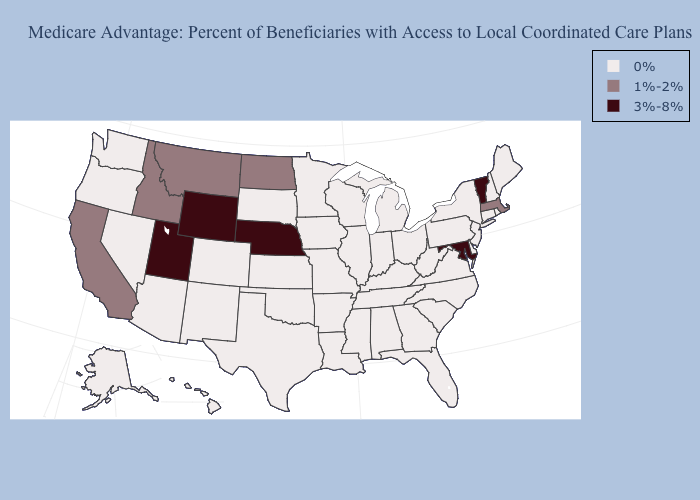Name the states that have a value in the range 3%-8%?
Be succinct. Maryland, Nebraska, Utah, Vermont, Wyoming. Name the states that have a value in the range 0%?
Be succinct. Colorado, Connecticut, Delaware, Florida, Georgia, Hawaii, Iowa, Illinois, Indiana, Kansas, Kentucky, Louisiana, Maine, Michigan, Minnesota, Missouri, Mississippi, North Carolina, New Hampshire, New Jersey, New Mexico, Nevada, New York, Ohio, Oklahoma, Oregon, Pennsylvania, Rhode Island, South Carolina, South Dakota, Alaska, Tennessee, Texas, Virginia, Washington, Wisconsin, West Virginia, Alabama, Arkansas, Arizona. Does the first symbol in the legend represent the smallest category?
Keep it brief. Yes. What is the lowest value in the USA?
Keep it brief. 0%. Name the states that have a value in the range 0%?
Concise answer only. Colorado, Connecticut, Delaware, Florida, Georgia, Hawaii, Iowa, Illinois, Indiana, Kansas, Kentucky, Louisiana, Maine, Michigan, Minnesota, Missouri, Mississippi, North Carolina, New Hampshire, New Jersey, New Mexico, Nevada, New York, Ohio, Oklahoma, Oregon, Pennsylvania, Rhode Island, South Carolina, South Dakota, Alaska, Tennessee, Texas, Virginia, Washington, Wisconsin, West Virginia, Alabama, Arkansas, Arizona. Does the first symbol in the legend represent the smallest category?
Concise answer only. Yes. Which states have the lowest value in the USA?
Keep it brief. Colorado, Connecticut, Delaware, Florida, Georgia, Hawaii, Iowa, Illinois, Indiana, Kansas, Kentucky, Louisiana, Maine, Michigan, Minnesota, Missouri, Mississippi, North Carolina, New Hampshire, New Jersey, New Mexico, Nevada, New York, Ohio, Oklahoma, Oregon, Pennsylvania, Rhode Island, South Carolina, South Dakota, Alaska, Tennessee, Texas, Virginia, Washington, Wisconsin, West Virginia, Alabama, Arkansas, Arizona. What is the value of Florida?
Quick response, please. 0%. Name the states that have a value in the range 1%-2%?
Write a very short answer. California, Idaho, Massachusetts, Montana, North Dakota. Is the legend a continuous bar?
Keep it brief. No. Name the states that have a value in the range 3%-8%?
Quick response, please. Maryland, Nebraska, Utah, Vermont, Wyoming. Name the states that have a value in the range 3%-8%?
Keep it brief. Maryland, Nebraska, Utah, Vermont, Wyoming. What is the value of North Dakota?
Short answer required. 1%-2%. Among the states that border Ohio , which have the highest value?
Be succinct. Indiana, Kentucky, Michigan, Pennsylvania, West Virginia. What is the value of Wyoming?
Be succinct. 3%-8%. 